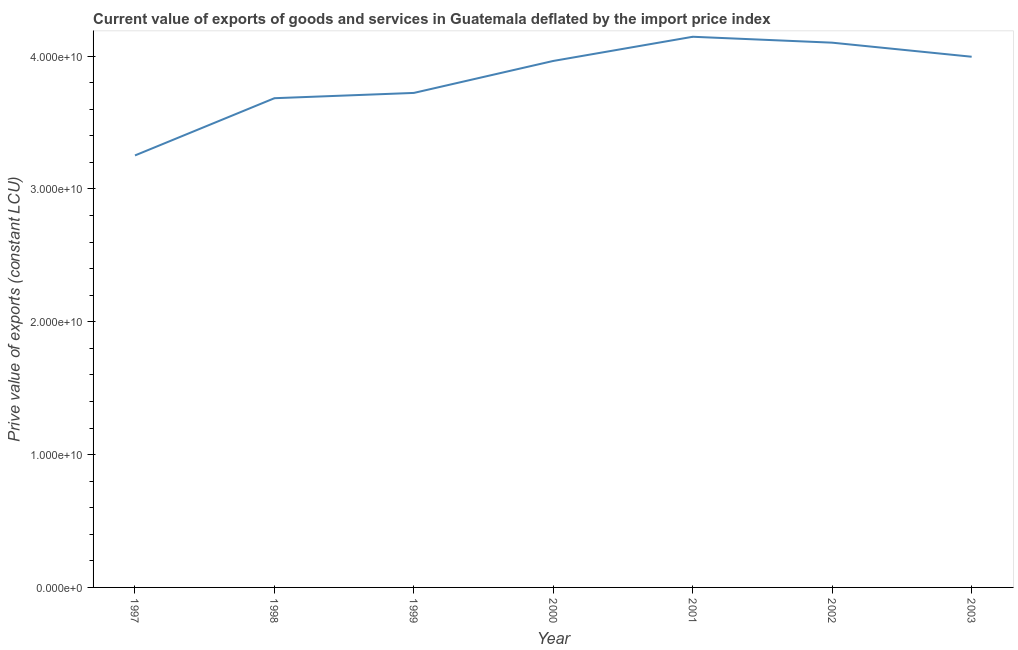What is the price value of exports in 1999?
Provide a succinct answer. 3.72e+1. Across all years, what is the maximum price value of exports?
Provide a short and direct response. 4.15e+1. Across all years, what is the minimum price value of exports?
Give a very brief answer. 3.25e+1. In which year was the price value of exports maximum?
Make the answer very short. 2001. What is the sum of the price value of exports?
Give a very brief answer. 2.69e+11. What is the difference between the price value of exports in 1998 and 1999?
Keep it short and to the point. -3.98e+08. What is the average price value of exports per year?
Keep it short and to the point. 3.84e+1. What is the median price value of exports?
Make the answer very short. 3.96e+1. What is the ratio of the price value of exports in 2002 to that in 2003?
Make the answer very short. 1.03. Is the price value of exports in 1998 less than that in 2003?
Provide a short and direct response. Yes. What is the difference between the highest and the second highest price value of exports?
Give a very brief answer. 4.46e+08. Is the sum of the price value of exports in 1997 and 2001 greater than the maximum price value of exports across all years?
Provide a short and direct response. Yes. What is the difference between the highest and the lowest price value of exports?
Provide a short and direct response. 8.93e+09. In how many years, is the price value of exports greater than the average price value of exports taken over all years?
Offer a very short reply. 4. Does the graph contain grids?
Provide a short and direct response. No. What is the title of the graph?
Ensure brevity in your answer.  Current value of exports of goods and services in Guatemala deflated by the import price index. What is the label or title of the X-axis?
Provide a short and direct response. Year. What is the label or title of the Y-axis?
Your answer should be compact. Prive value of exports (constant LCU). What is the Prive value of exports (constant LCU) in 1997?
Provide a succinct answer. 3.25e+1. What is the Prive value of exports (constant LCU) of 1998?
Make the answer very short. 3.68e+1. What is the Prive value of exports (constant LCU) in 1999?
Offer a terse response. 3.72e+1. What is the Prive value of exports (constant LCU) in 2000?
Make the answer very short. 3.96e+1. What is the Prive value of exports (constant LCU) of 2001?
Your answer should be compact. 4.15e+1. What is the Prive value of exports (constant LCU) in 2002?
Your answer should be very brief. 4.10e+1. What is the Prive value of exports (constant LCU) of 2003?
Keep it short and to the point. 4.00e+1. What is the difference between the Prive value of exports (constant LCU) in 1997 and 1998?
Provide a succinct answer. -4.31e+09. What is the difference between the Prive value of exports (constant LCU) in 1997 and 1999?
Make the answer very short. -4.71e+09. What is the difference between the Prive value of exports (constant LCU) in 1997 and 2000?
Offer a terse response. -7.11e+09. What is the difference between the Prive value of exports (constant LCU) in 1997 and 2001?
Ensure brevity in your answer.  -8.93e+09. What is the difference between the Prive value of exports (constant LCU) in 1997 and 2002?
Provide a succinct answer. -8.49e+09. What is the difference between the Prive value of exports (constant LCU) in 1997 and 2003?
Give a very brief answer. -7.43e+09. What is the difference between the Prive value of exports (constant LCU) in 1998 and 1999?
Your response must be concise. -3.98e+08. What is the difference between the Prive value of exports (constant LCU) in 1998 and 2000?
Your answer should be compact. -2.81e+09. What is the difference between the Prive value of exports (constant LCU) in 1998 and 2001?
Ensure brevity in your answer.  -4.63e+09. What is the difference between the Prive value of exports (constant LCU) in 1998 and 2002?
Your answer should be very brief. -4.18e+09. What is the difference between the Prive value of exports (constant LCU) in 1998 and 2003?
Provide a succinct answer. -3.12e+09. What is the difference between the Prive value of exports (constant LCU) in 1999 and 2000?
Your answer should be very brief. -2.41e+09. What is the difference between the Prive value of exports (constant LCU) in 1999 and 2001?
Make the answer very short. -4.23e+09. What is the difference between the Prive value of exports (constant LCU) in 1999 and 2002?
Make the answer very short. -3.78e+09. What is the difference between the Prive value of exports (constant LCU) in 1999 and 2003?
Give a very brief answer. -2.72e+09. What is the difference between the Prive value of exports (constant LCU) in 2000 and 2001?
Keep it short and to the point. -1.82e+09. What is the difference between the Prive value of exports (constant LCU) in 2000 and 2002?
Offer a terse response. -1.37e+09. What is the difference between the Prive value of exports (constant LCU) in 2000 and 2003?
Your answer should be very brief. -3.15e+08. What is the difference between the Prive value of exports (constant LCU) in 2001 and 2002?
Give a very brief answer. 4.46e+08. What is the difference between the Prive value of exports (constant LCU) in 2001 and 2003?
Keep it short and to the point. 1.50e+09. What is the difference between the Prive value of exports (constant LCU) in 2002 and 2003?
Your answer should be compact. 1.06e+09. What is the ratio of the Prive value of exports (constant LCU) in 1997 to that in 1998?
Keep it short and to the point. 0.88. What is the ratio of the Prive value of exports (constant LCU) in 1997 to that in 1999?
Ensure brevity in your answer.  0.87. What is the ratio of the Prive value of exports (constant LCU) in 1997 to that in 2000?
Give a very brief answer. 0.82. What is the ratio of the Prive value of exports (constant LCU) in 1997 to that in 2001?
Make the answer very short. 0.78. What is the ratio of the Prive value of exports (constant LCU) in 1997 to that in 2002?
Give a very brief answer. 0.79. What is the ratio of the Prive value of exports (constant LCU) in 1997 to that in 2003?
Provide a short and direct response. 0.81. What is the ratio of the Prive value of exports (constant LCU) in 1998 to that in 2000?
Provide a succinct answer. 0.93. What is the ratio of the Prive value of exports (constant LCU) in 1998 to that in 2001?
Ensure brevity in your answer.  0.89. What is the ratio of the Prive value of exports (constant LCU) in 1998 to that in 2002?
Your answer should be very brief. 0.9. What is the ratio of the Prive value of exports (constant LCU) in 1998 to that in 2003?
Offer a very short reply. 0.92. What is the ratio of the Prive value of exports (constant LCU) in 1999 to that in 2000?
Give a very brief answer. 0.94. What is the ratio of the Prive value of exports (constant LCU) in 1999 to that in 2001?
Make the answer very short. 0.9. What is the ratio of the Prive value of exports (constant LCU) in 1999 to that in 2002?
Offer a terse response. 0.91. What is the ratio of the Prive value of exports (constant LCU) in 1999 to that in 2003?
Keep it short and to the point. 0.93. What is the ratio of the Prive value of exports (constant LCU) in 2000 to that in 2001?
Provide a short and direct response. 0.96. What is the ratio of the Prive value of exports (constant LCU) in 2001 to that in 2003?
Your answer should be compact. 1.04. What is the ratio of the Prive value of exports (constant LCU) in 2002 to that in 2003?
Your answer should be very brief. 1.03. 